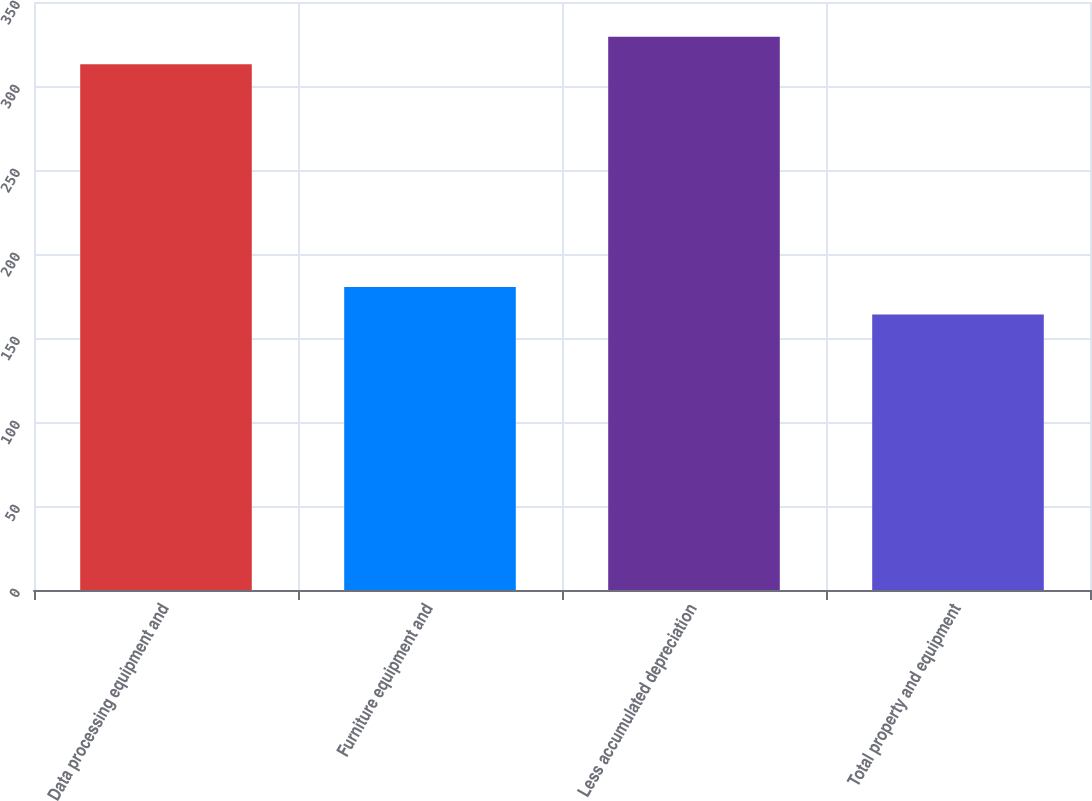<chart> <loc_0><loc_0><loc_500><loc_500><bar_chart><fcel>Data processing equipment and<fcel>Furniture equipment and<fcel>Less accumulated depreciation<fcel>Total property and equipment<nl><fcel>313<fcel>180.3<fcel>329.3<fcel>164<nl></chart> 